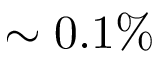Convert formula to latex. <formula><loc_0><loc_0><loc_500><loc_500>\sim 0 . 1 \%</formula> 